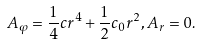Convert formula to latex. <formula><loc_0><loc_0><loc_500><loc_500>A _ { \varphi } = \frac { 1 } { 4 } c r ^ { 4 } + \frac { 1 } { 2 } c _ { 0 } r ^ { 2 } , A _ { r } = 0 .</formula> 